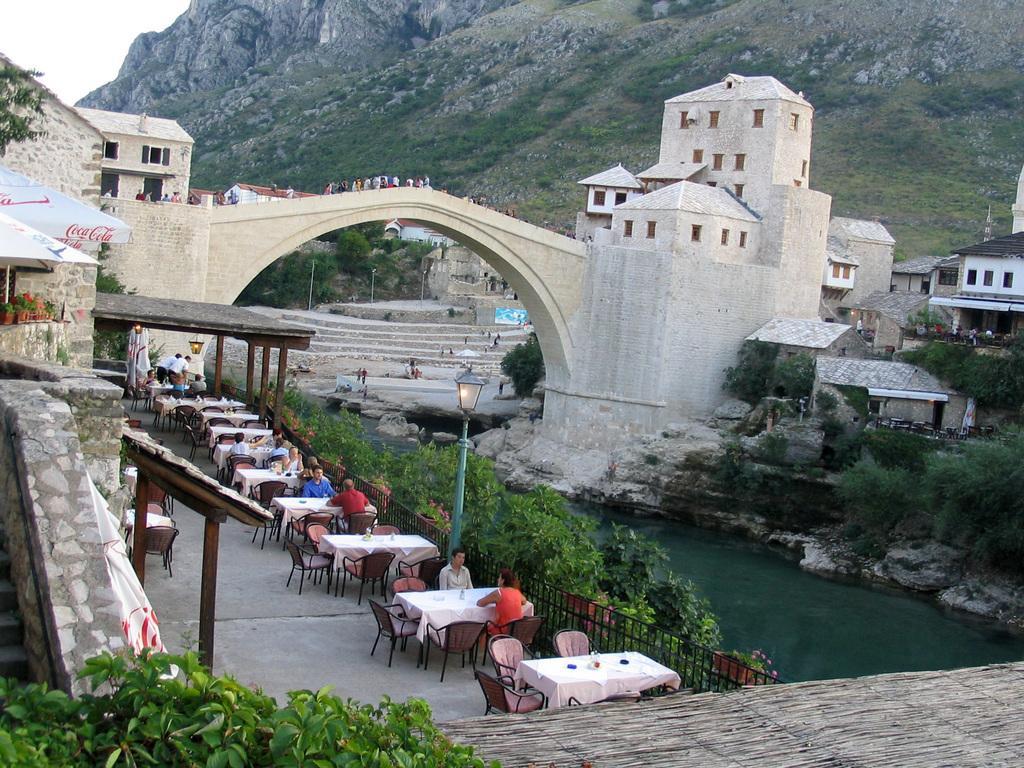Could you give a brief overview of what you see in this image? In this image few persons are sitting on the chair before a table. Two persons are standing. Few persons are on the bridge and few persons are on the stairs. At the left side there are few houses having pots with plants, staircase and leaves at the left bottom corner. At the right side there is water covered both sides with plants. There is a fence and a lamp. There is a hill at the top of the image. 